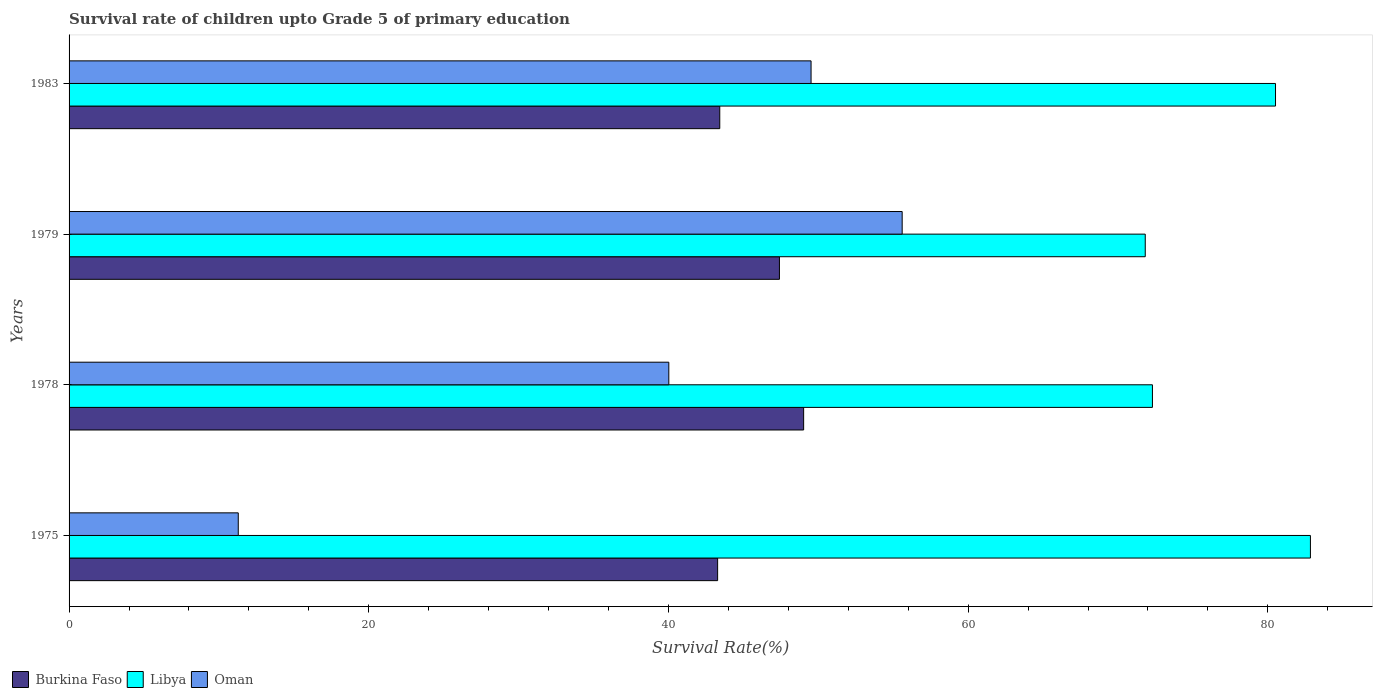How many different coloured bars are there?
Make the answer very short. 3. Are the number of bars on each tick of the Y-axis equal?
Provide a succinct answer. Yes. How many bars are there on the 1st tick from the bottom?
Your answer should be very brief. 3. What is the label of the 4th group of bars from the top?
Keep it short and to the point. 1975. In how many cases, is the number of bars for a given year not equal to the number of legend labels?
Your answer should be compact. 0. What is the survival rate of children in Libya in 1975?
Give a very brief answer. 82.84. Across all years, what is the maximum survival rate of children in Burkina Faso?
Offer a very short reply. 49.02. Across all years, what is the minimum survival rate of children in Oman?
Provide a short and direct response. 11.29. In which year was the survival rate of children in Burkina Faso maximum?
Make the answer very short. 1978. In which year was the survival rate of children in Oman minimum?
Make the answer very short. 1975. What is the total survival rate of children in Oman in the graph?
Offer a terse response. 156.43. What is the difference between the survival rate of children in Burkina Faso in 1975 and that in 1978?
Give a very brief answer. -5.74. What is the difference between the survival rate of children in Libya in 1979 and the survival rate of children in Burkina Faso in 1975?
Provide a succinct answer. 28.54. What is the average survival rate of children in Oman per year?
Make the answer very short. 39.11. In the year 1983, what is the difference between the survival rate of children in Libya and survival rate of children in Burkina Faso?
Make the answer very short. 37.09. In how many years, is the survival rate of children in Oman greater than 64 %?
Keep it short and to the point. 0. What is the ratio of the survival rate of children in Burkina Faso in 1975 to that in 1978?
Ensure brevity in your answer.  0.88. What is the difference between the highest and the second highest survival rate of children in Burkina Faso?
Provide a short and direct response. 1.62. What is the difference between the highest and the lowest survival rate of children in Burkina Faso?
Provide a succinct answer. 5.74. In how many years, is the survival rate of children in Libya greater than the average survival rate of children in Libya taken over all years?
Provide a succinct answer. 2. Is the sum of the survival rate of children in Libya in 1975 and 1983 greater than the maximum survival rate of children in Oman across all years?
Ensure brevity in your answer.  Yes. What does the 1st bar from the top in 1983 represents?
Offer a very short reply. Oman. What does the 1st bar from the bottom in 1978 represents?
Your answer should be compact. Burkina Faso. Are the values on the major ticks of X-axis written in scientific E-notation?
Your response must be concise. No. Where does the legend appear in the graph?
Offer a very short reply. Bottom left. What is the title of the graph?
Offer a terse response. Survival rate of children upto Grade 5 of primary education. What is the label or title of the X-axis?
Offer a very short reply. Survival Rate(%). What is the Survival Rate(%) in Burkina Faso in 1975?
Offer a terse response. 43.28. What is the Survival Rate(%) of Libya in 1975?
Ensure brevity in your answer.  82.84. What is the Survival Rate(%) in Oman in 1975?
Keep it short and to the point. 11.29. What is the Survival Rate(%) of Burkina Faso in 1978?
Your answer should be compact. 49.02. What is the Survival Rate(%) of Libya in 1978?
Offer a very short reply. 72.3. What is the Survival Rate(%) in Oman in 1978?
Your answer should be compact. 40.03. What is the Survival Rate(%) in Burkina Faso in 1979?
Provide a short and direct response. 47.41. What is the Survival Rate(%) of Libya in 1979?
Your answer should be compact. 71.82. What is the Survival Rate(%) in Oman in 1979?
Your response must be concise. 55.6. What is the Survival Rate(%) of Burkina Faso in 1983?
Your answer should be compact. 43.43. What is the Survival Rate(%) of Libya in 1983?
Ensure brevity in your answer.  80.51. What is the Survival Rate(%) of Oman in 1983?
Provide a succinct answer. 49.52. Across all years, what is the maximum Survival Rate(%) of Burkina Faso?
Give a very brief answer. 49.02. Across all years, what is the maximum Survival Rate(%) in Libya?
Provide a succinct answer. 82.84. Across all years, what is the maximum Survival Rate(%) of Oman?
Offer a terse response. 55.6. Across all years, what is the minimum Survival Rate(%) of Burkina Faso?
Ensure brevity in your answer.  43.28. Across all years, what is the minimum Survival Rate(%) of Libya?
Provide a succinct answer. 71.82. Across all years, what is the minimum Survival Rate(%) in Oman?
Provide a succinct answer. 11.29. What is the total Survival Rate(%) in Burkina Faso in the graph?
Your answer should be very brief. 183.14. What is the total Survival Rate(%) in Libya in the graph?
Make the answer very short. 307.48. What is the total Survival Rate(%) in Oman in the graph?
Offer a very short reply. 156.43. What is the difference between the Survival Rate(%) in Burkina Faso in 1975 and that in 1978?
Offer a terse response. -5.74. What is the difference between the Survival Rate(%) of Libya in 1975 and that in 1978?
Give a very brief answer. 10.54. What is the difference between the Survival Rate(%) of Oman in 1975 and that in 1978?
Make the answer very short. -28.73. What is the difference between the Survival Rate(%) in Burkina Faso in 1975 and that in 1979?
Provide a short and direct response. -4.12. What is the difference between the Survival Rate(%) of Libya in 1975 and that in 1979?
Provide a short and direct response. 11.02. What is the difference between the Survival Rate(%) of Oman in 1975 and that in 1979?
Your response must be concise. -44.31. What is the difference between the Survival Rate(%) in Burkina Faso in 1975 and that in 1983?
Make the answer very short. -0.14. What is the difference between the Survival Rate(%) in Libya in 1975 and that in 1983?
Your answer should be compact. 2.33. What is the difference between the Survival Rate(%) of Oman in 1975 and that in 1983?
Offer a very short reply. -38.23. What is the difference between the Survival Rate(%) of Burkina Faso in 1978 and that in 1979?
Your answer should be very brief. 1.62. What is the difference between the Survival Rate(%) in Libya in 1978 and that in 1979?
Offer a very short reply. 0.48. What is the difference between the Survival Rate(%) of Oman in 1978 and that in 1979?
Your answer should be very brief. -15.57. What is the difference between the Survival Rate(%) in Burkina Faso in 1978 and that in 1983?
Provide a short and direct response. 5.6. What is the difference between the Survival Rate(%) in Libya in 1978 and that in 1983?
Ensure brevity in your answer.  -8.21. What is the difference between the Survival Rate(%) of Oman in 1978 and that in 1983?
Keep it short and to the point. -9.49. What is the difference between the Survival Rate(%) in Burkina Faso in 1979 and that in 1983?
Offer a terse response. 3.98. What is the difference between the Survival Rate(%) in Libya in 1979 and that in 1983?
Give a very brief answer. -8.69. What is the difference between the Survival Rate(%) of Oman in 1979 and that in 1983?
Your answer should be compact. 6.08. What is the difference between the Survival Rate(%) in Burkina Faso in 1975 and the Survival Rate(%) in Libya in 1978?
Make the answer very short. -29.02. What is the difference between the Survival Rate(%) of Burkina Faso in 1975 and the Survival Rate(%) of Oman in 1978?
Give a very brief answer. 3.26. What is the difference between the Survival Rate(%) of Libya in 1975 and the Survival Rate(%) of Oman in 1978?
Provide a short and direct response. 42.82. What is the difference between the Survival Rate(%) in Burkina Faso in 1975 and the Survival Rate(%) in Libya in 1979?
Provide a short and direct response. -28.54. What is the difference between the Survival Rate(%) of Burkina Faso in 1975 and the Survival Rate(%) of Oman in 1979?
Your response must be concise. -12.32. What is the difference between the Survival Rate(%) of Libya in 1975 and the Survival Rate(%) of Oman in 1979?
Your answer should be very brief. 27.25. What is the difference between the Survival Rate(%) of Burkina Faso in 1975 and the Survival Rate(%) of Libya in 1983?
Offer a terse response. -37.23. What is the difference between the Survival Rate(%) of Burkina Faso in 1975 and the Survival Rate(%) of Oman in 1983?
Your answer should be very brief. -6.24. What is the difference between the Survival Rate(%) of Libya in 1975 and the Survival Rate(%) of Oman in 1983?
Ensure brevity in your answer.  33.33. What is the difference between the Survival Rate(%) of Burkina Faso in 1978 and the Survival Rate(%) of Libya in 1979?
Keep it short and to the point. -22.8. What is the difference between the Survival Rate(%) in Burkina Faso in 1978 and the Survival Rate(%) in Oman in 1979?
Provide a succinct answer. -6.58. What is the difference between the Survival Rate(%) in Libya in 1978 and the Survival Rate(%) in Oman in 1979?
Offer a terse response. 16.7. What is the difference between the Survival Rate(%) of Burkina Faso in 1978 and the Survival Rate(%) of Libya in 1983?
Give a very brief answer. -31.49. What is the difference between the Survival Rate(%) in Burkina Faso in 1978 and the Survival Rate(%) in Oman in 1983?
Your response must be concise. -0.5. What is the difference between the Survival Rate(%) in Libya in 1978 and the Survival Rate(%) in Oman in 1983?
Your answer should be compact. 22.78. What is the difference between the Survival Rate(%) in Burkina Faso in 1979 and the Survival Rate(%) in Libya in 1983?
Make the answer very short. -33.11. What is the difference between the Survival Rate(%) of Burkina Faso in 1979 and the Survival Rate(%) of Oman in 1983?
Make the answer very short. -2.11. What is the difference between the Survival Rate(%) in Libya in 1979 and the Survival Rate(%) in Oman in 1983?
Provide a succinct answer. 22.3. What is the average Survival Rate(%) of Burkina Faso per year?
Provide a short and direct response. 45.78. What is the average Survival Rate(%) of Libya per year?
Offer a very short reply. 76.87. What is the average Survival Rate(%) of Oman per year?
Keep it short and to the point. 39.11. In the year 1975, what is the difference between the Survival Rate(%) of Burkina Faso and Survival Rate(%) of Libya?
Provide a succinct answer. -39.56. In the year 1975, what is the difference between the Survival Rate(%) in Burkina Faso and Survival Rate(%) in Oman?
Your answer should be compact. 31.99. In the year 1975, what is the difference between the Survival Rate(%) in Libya and Survival Rate(%) in Oman?
Your response must be concise. 71.55. In the year 1978, what is the difference between the Survival Rate(%) in Burkina Faso and Survival Rate(%) in Libya?
Make the answer very short. -23.28. In the year 1978, what is the difference between the Survival Rate(%) of Burkina Faso and Survival Rate(%) of Oman?
Provide a short and direct response. 9. In the year 1978, what is the difference between the Survival Rate(%) in Libya and Survival Rate(%) in Oman?
Make the answer very short. 32.27. In the year 1979, what is the difference between the Survival Rate(%) in Burkina Faso and Survival Rate(%) in Libya?
Keep it short and to the point. -24.41. In the year 1979, what is the difference between the Survival Rate(%) of Burkina Faso and Survival Rate(%) of Oman?
Your response must be concise. -8.19. In the year 1979, what is the difference between the Survival Rate(%) of Libya and Survival Rate(%) of Oman?
Ensure brevity in your answer.  16.22. In the year 1983, what is the difference between the Survival Rate(%) of Burkina Faso and Survival Rate(%) of Libya?
Offer a very short reply. -37.09. In the year 1983, what is the difference between the Survival Rate(%) of Burkina Faso and Survival Rate(%) of Oman?
Make the answer very short. -6.09. In the year 1983, what is the difference between the Survival Rate(%) of Libya and Survival Rate(%) of Oman?
Your answer should be compact. 31. What is the ratio of the Survival Rate(%) of Burkina Faso in 1975 to that in 1978?
Your response must be concise. 0.88. What is the ratio of the Survival Rate(%) in Libya in 1975 to that in 1978?
Your answer should be very brief. 1.15. What is the ratio of the Survival Rate(%) of Oman in 1975 to that in 1978?
Your answer should be compact. 0.28. What is the ratio of the Survival Rate(%) in Libya in 1975 to that in 1979?
Your response must be concise. 1.15. What is the ratio of the Survival Rate(%) in Oman in 1975 to that in 1979?
Give a very brief answer. 0.2. What is the ratio of the Survival Rate(%) in Burkina Faso in 1975 to that in 1983?
Give a very brief answer. 1. What is the ratio of the Survival Rate(%) in Libya in 1975 to that in 1983?
Give a very brief answer. 1.03. What is the ratio of the Survival Rate(%) in Oman in 1975 to that in 1983?
Give a very brief answer. 0.23. What is the ratio of the Survival Rate(%) of Burkina Faso in 1978 to that in 1979?
Your answer should be very brief. 1.03. What is the ratio of the Survival Rate(%) in Libya in 1978 to that in 1979?
Provide a succinct answer. 1.01. What is the ratio of the Survival Rate(%) in Oman in 1978 to that in 1979?
Make the answer very short. 0.72. What is the ratio of the Survival Rate(%) of Burkina Faso in 1978 to that in 1983?
Your answer should be compact. 1.13. What is the ratio of the Survival Rate(%) of Libya in 1978 to that in 1983?
Keep it short and to the point. 0.9. What is the ratio of the Survival Rate(%) in Oman in 1978 to that in 1983?
Your answer should be very brief. 0.81. What is the ratio of the Survival Rate(%) of Burkina Faso in 1979 to that in 1983?
Give a very brief answer. 1.09. What is the ratio of the Survival Rate(%) of Libya in 1979 to that in 1983?
Your answer should be compact. 0.89. What is the ratio of the Survival Rate(%) in Oman in 1979 to that in 1983?
Ensure brevity in your answer.  1.12. What is the difference between the highest and the second highest Survival Rate(%) of Burkina Faso?
Your answer should be compact. 1.62. What is the difference between the highest and the second highest Survival Rate(%) of Libya?
Your answer should be compact. 2.33. What is the difference between the highest and the second highest Survival Rate(%) in Oman?
Provide a short and direct response. 6.08. What is the difference between the highest and the lowest Survival Rate(%) in Burkina Faso?
Offer a terse response. 5.74. What is the difference between the highest and the lowest Survival Rate(%) in Libya?
Your response must be concise. 11.02. What is the difference between the highest and the lowest Survival Rate(%) in Oman?
Keep it short and to the point. 44.31. 